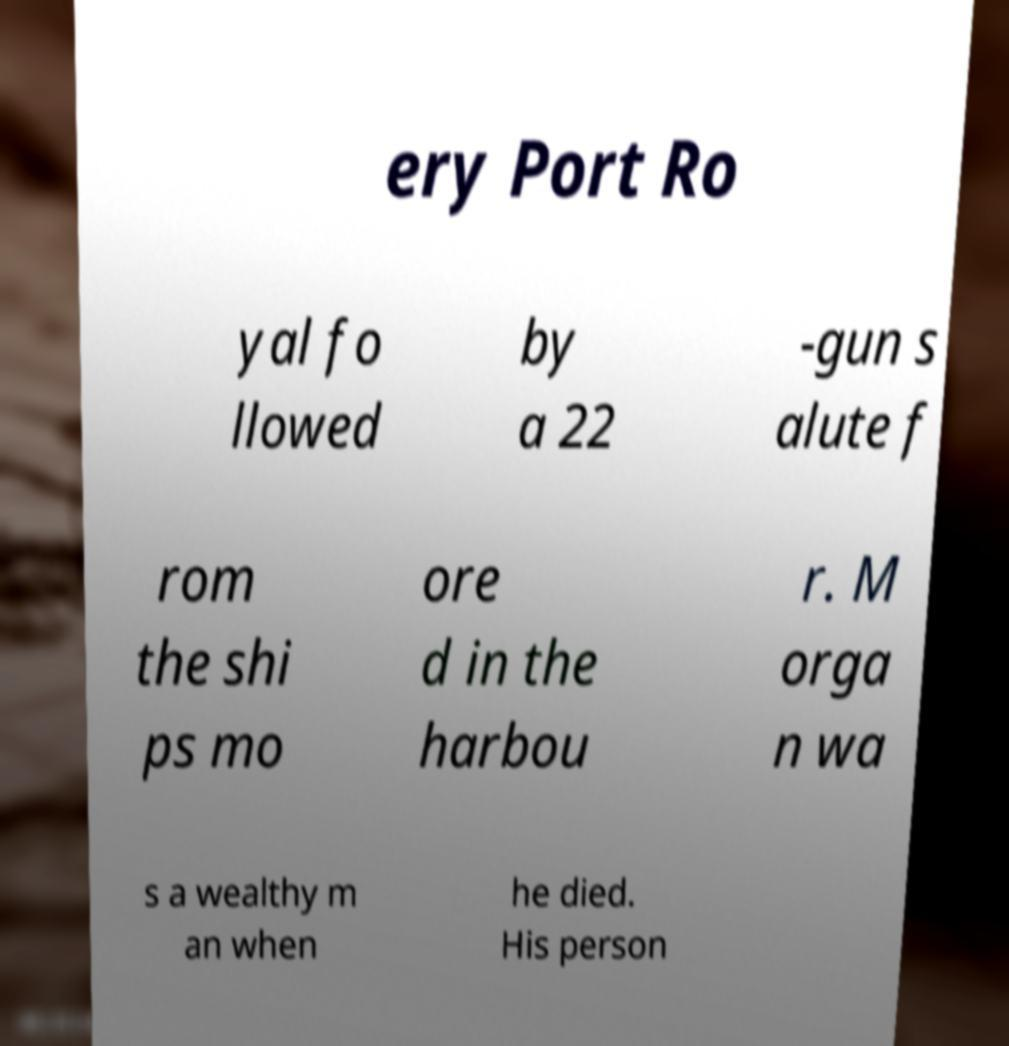Could you extract and type out the text from this image? ery Port Ro yal fo llowed by a 22 -gun s alute f rom the shi ps mo ore d in the harbou r. M orga n wa s a wealthy m an when he died. His person 